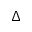<formula> <loc_0><loc_0><loc_500><loc_500>\Delta</formula> 